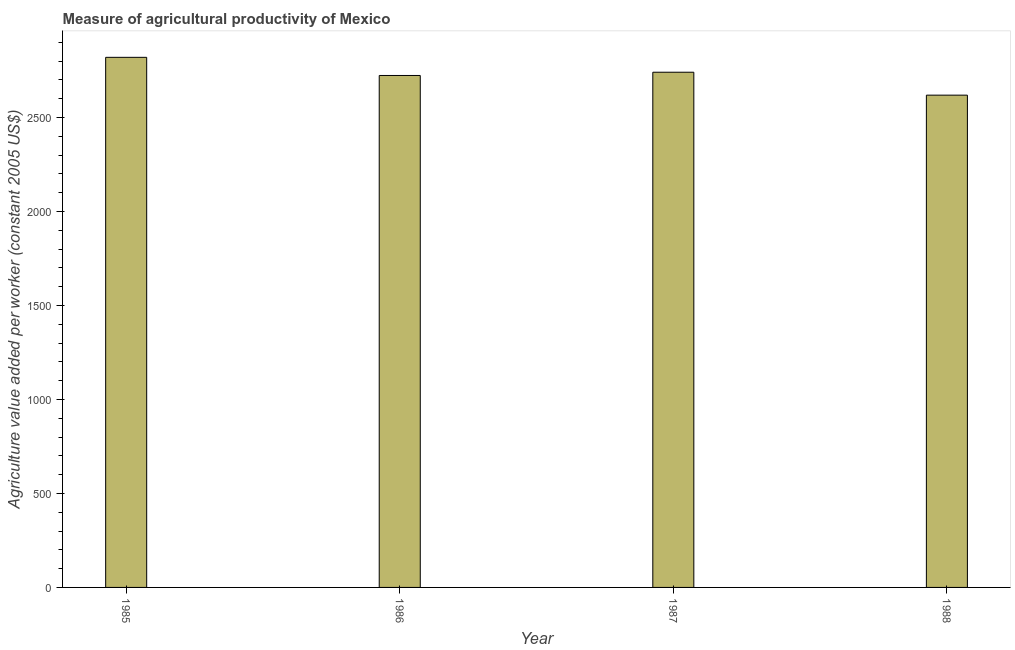Does the graph contain any zero values?
Give a very brief answer. No. Does the graph contain grids?
Your answer should be very brief. No. What is the title of the graph?
Make the answer very short. Measure of agricultural productivity of Mexico. What is the label or title of the Y-axis?
Keep it short and to the point. Agriculture value added per worker (constant 2005 US$). What is the agriculture value added per worker in 1985?
Ensure brevity in your answer.  2819.93. Across all years, what is the maximum agriculture value added per worker?
Provide a short and direct response. 2819.93. Across all years, what is the minimum agriculture value added per worker?
Offer a very short reply. 2618.75. What is the sum of the agriculture value added per worker?
Provide a short and direct response. 1.09e+04. What is the difference between the agriculture value added per worker in 1985 and 1986?
Keep it short and to the point. 96.54. What is the average agriculture value added per worker per year?
Offer a terse response. 2725.69. What is the median agriculture value added per worker?
Keep it short and to the point. 2732.04. What is the ratio of the agriculture value added per worker in 1986 to that in 1987?
Ensure brevity in your answer.  0.99. Is the agriculture value added per worker in 1987 less than that in 1988?
Your answer should be compact. No. What is the difference between the highest and the second highest agriculture value added per worker?
Ensure brevity in your answer.  79.24. What is the difference between the highest and the lowest agriculture value added per worker?
Provide a succinct answer. 201.19. How many years are there in the graph?
Provide a succinct answer. 4. Are the values on the major ticks of Y-axis written in scientific E-notation?
Give a very brief answer. No. What is the Agriculture value added per worker (constant 2005 US$) in 1985?
Offer a terse response. 2819.93. What is the Agriculture value added per worker (constant 2005 US$) of 1986?
Your answer should be compact. 2723.4. What is the Agriculture value added per worker (constant 2005 US$) in 1987?
Your response must be concise. 2740.69. What is the Agriculture value added per worker (constant 2005 US$) in 1988?
Provide a succinct answer. 2618.75. What is the difference between the Agriculture value added per worker (constant 2005 US$) in 1985 and 1986?
Make the answer very short. 96.54. What is the difference between the Agriculture value added per worker (constant 2005 US$) in 1985 and 1987?
Offer a terse response. 79.24. What is the difference between the Agriculture value added per worker (constant 2005 US$) in 1985 and 1988?
Give a very brief answer. 201.19. What is the difference between the Agriculture value added per worker (constant 2005 US$) in 1986 and 1987?
Keep it short and to the point. -17.29. What is the difference between the Agriculture value added per worker (constant 2005 US$) in 1986 and 1988?
Keep it short and to the point. 104.65. What is the difference between the Agriculture value added per worker (constant 2005 US$) in 1987 and 1988?
Make the answer very short. 121.94. What is the ratio of the Agriculture value added per worker (constant 2005 US$) in 1985 to that in 1986?
Offer a very short reply. 1.03. What is the ratio of the Agriculture value added per worker (constant 2005 US$) in 1985 to that in 1987?
Your response must be concise. 1.03. What is the ratio of the Agriculture value added per worker (constant 2005 US$) in 1985 to that in 1988?
Make the answer very short. 1.08. What is the ratio of the Agriculture value added per worker (constant 2005 US$) in 1986 to that in 1987?
Your answer should be very brief. 0.99. What is the ratio of the Agriculture value added per worker (constant 2005 US$) in 1987 to that in 1988?
Provide a short and direct response. 1.05. 